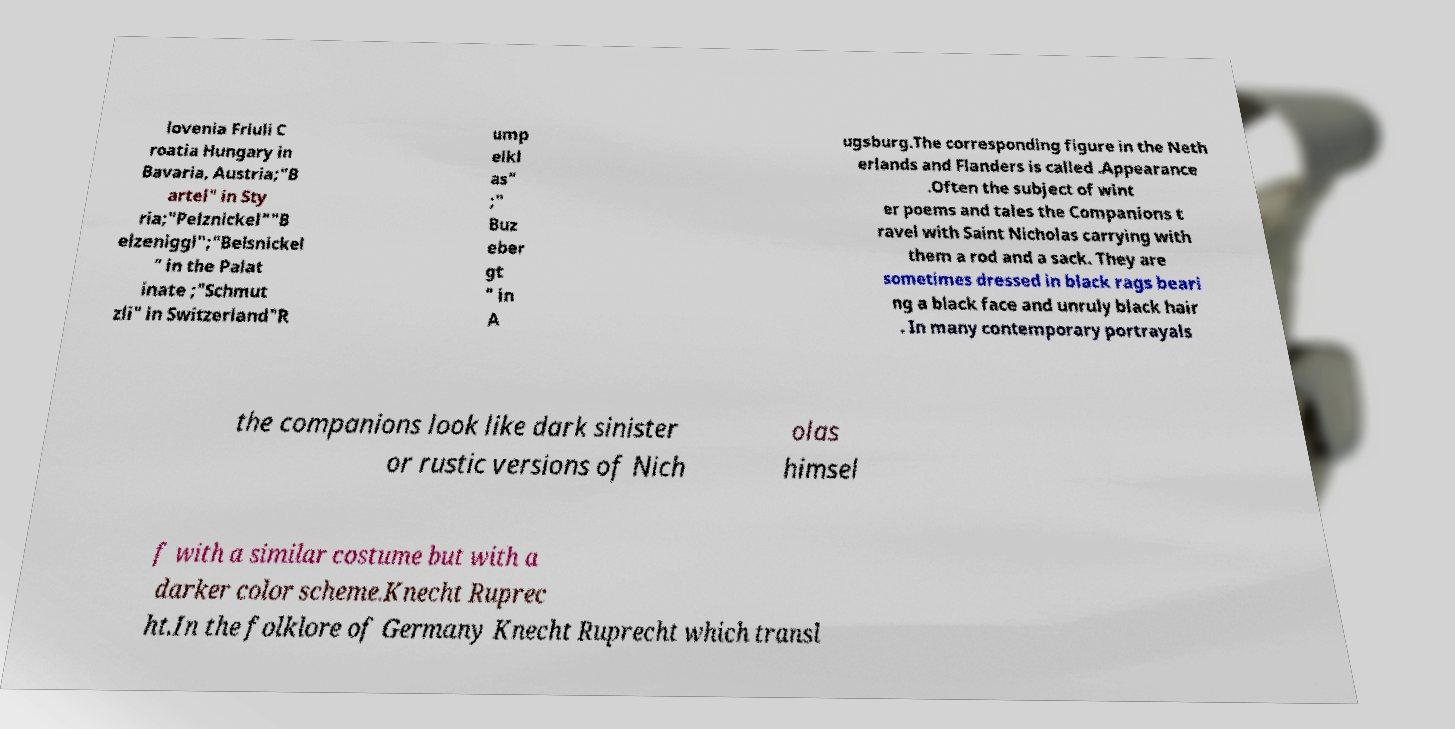Can you accurately transcribe the text from the provided image for me? lovenia Friuli C roatia Hungary in Bavaria, Austria;"B artel" in Sty ria;"Pelznickel""B elzeniggl";"Belsnickel " in the Palat inate ;"Schmut zli" in Switzerland"R ump elkl as" ;" Buz eber gt " in A ugsburg.The corresponding figure in the Neth erlands and Flanders is called .Appearance .Often the subject of wint er poems and tales the Companions t ravel with Saint Nicholas carrying with them a rod and a sack. They are sometimes dressed in black rags beari ng a black face and unruly black hair . In many contemporary portrayals the companions look like dark sinister or rustic versions of Nich olas himsel f with a similar costume but with a darker color scheme.Knecht Ruprec ht.In the folklore of Germany Knecht Ruprecht which transl 